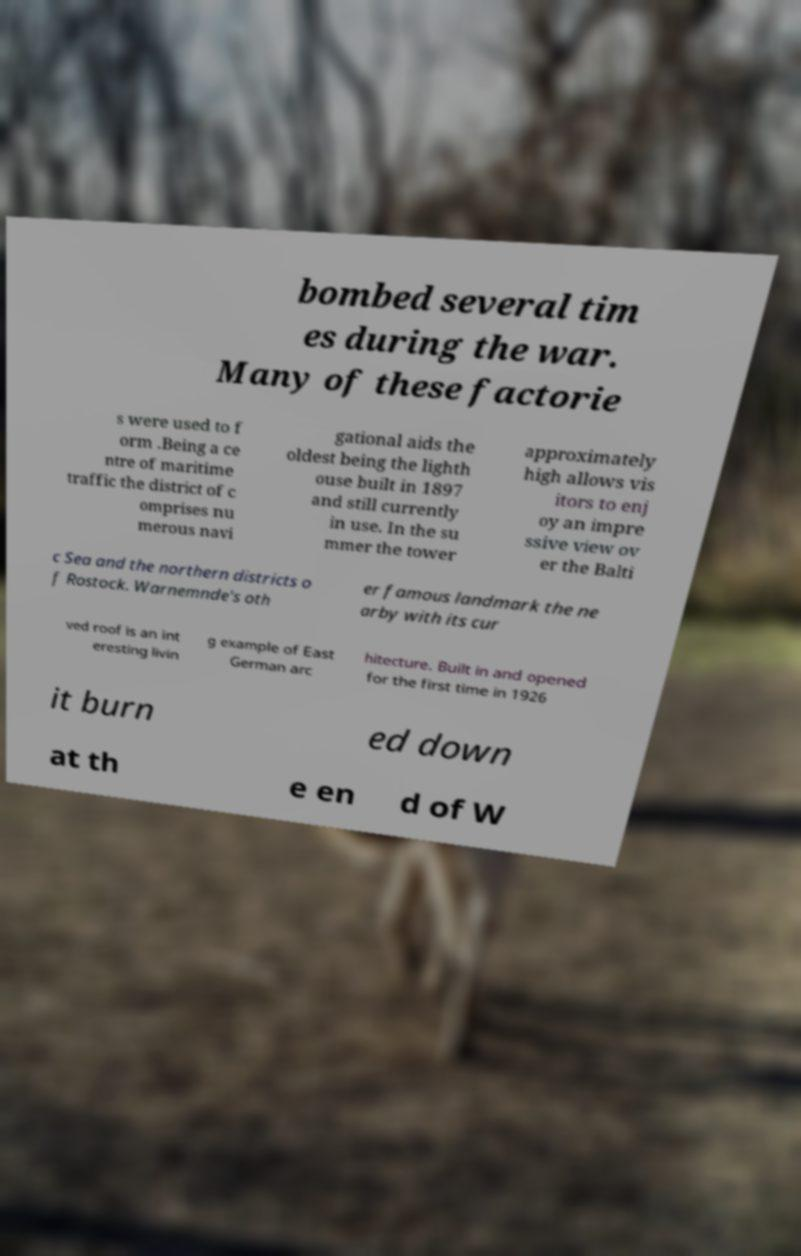Could you assist in decoding the text presented in this image and type it out clearly? bombed several tim es during the war. Many of these factorie s were used to f orm .Being a ce ntre of maritime traffic the district of c omprises nu merous navi gational aids the oldest being the lighth ouse built in 1897 and still currently in use. In the su mmer the tower approximately high allows vis itors to enj oy an impre ssive view ov er the Balti c Sea and the northern districts o f Rostock. Warnemnde's oth er famous landmark the ne arby with its cur ved roof is an int eresting livin g example of East German arc hitecture. Built in and opened for the first time in 1926 it burn ed down at th e en d of W 